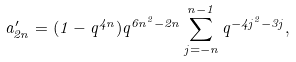Convert formula to latex. <formula><loc_0><loc_0><loc_500><loc_500>a ^ { \prime } _ { 2 n } = ( 1 - q ^ { 4 n } ) q ^ { 6 n ^ { 2 } - 2 n } \sum _ { j = - n } ^ { n - 1 } q ^ { - 4 j ^ { 2 } - 3 j } ,</formula> 